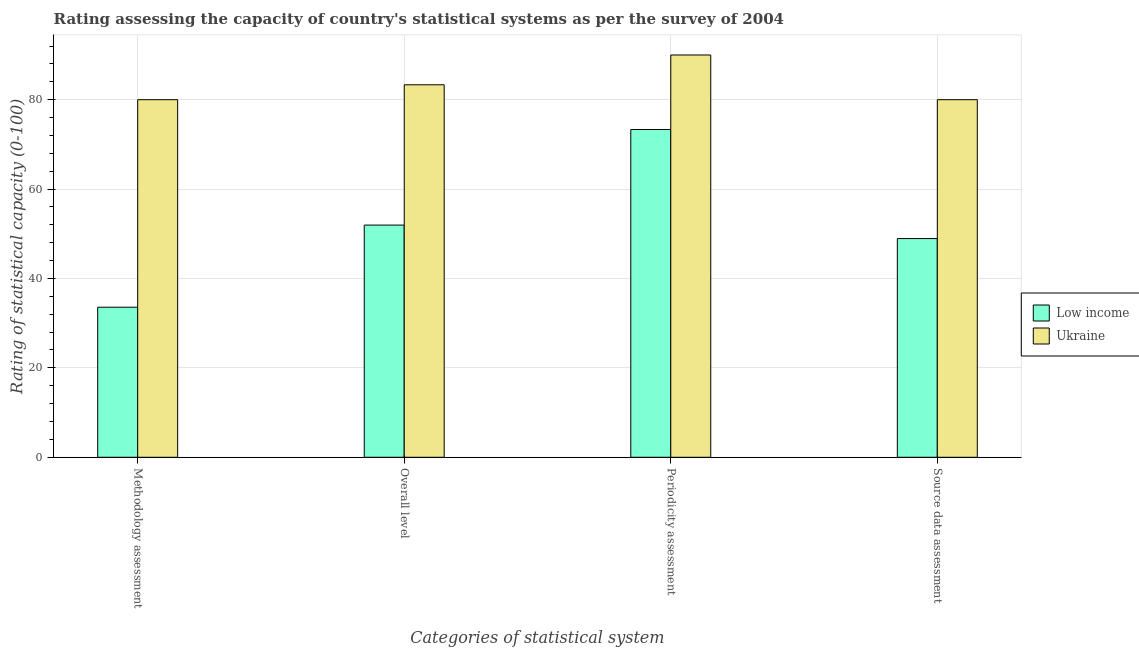How many different coloured bars are there?
Give a very brief answer. 2. What is the label of the 2nd group of bars from the left?
Your answer should be very brief. Overall level. What is the overall level rating in Low income?
Offer a very short reply. 51.94. Across all countries, what is the maximum periodicity assessment rating?
Provide a short and direct response. 90. Across all countries, what is the minimum periodicity assessment rating?
Your response must be concise. 73.33. In which country was the source data assessment rating maximum?
Offer a terse response. Ukraine. What is the total overall level rating in the graph?
Offer a terse response. 135.28. What is the difference between the overall level rating in Ukraine and that in Low income?
Make the answer very short. 31.39. What is the difference between the methodology assessment rating in Low income and the overall level rating in Ukraine?
Provide a succinct answer. -49.76. What is the average periodicity assessment rating per country?
Offer a very short reply. 81.67. What is the difference between the source data assessment rating and overall level rating in Ukraine?
Ensure brevity in your answer.  -3.33. In how many countries, is the source data assessment rating greater than 72 ?
Offer a very short reply. 1. What is the ratio of the overall level rating in Low income to that in Ukraine?
Your answer should be very brief. 0.62. Is the methodology assessment rating in Ukraine less than that in Low income?
Give a very brief answer. No. What is the difference between the highest and the second highest methodology assessment rating?
Ensure brevity in your answer.  46.43. What is the difference between the highest and the lowest overall level rating?
Provide a succinct answer. 31.39. In how many countries, is the source data assessment rating greater than the average source data assessment rating taken over all countries?
Provide a short and direct response. 1. Is the sum of the methodology assessment rating in Ukraine and Low income greater than the maximum overall level rating across all countries?
Your answer should be very brief. Yes. What does the 2nd bar from the left in Methodology assessment represents?
Ensure brevity in your answer.  Ukraine. What does the 2nd bar from the right in Overall level represents?
Your answer should be compact. Low income. How many bars are there?
Provide a succinct answer. 8. Are all the bars in the graph horizontal?
Your response must be concise. No. What is the difference between two consecutive major ticks on the Y-axis?
Keep it short and to the point. 20. Are the values on the major ticks of Y-axis written in scientific E-notation?
Your answer should be compact. No. Does the graph contain grids?
Provide a succinct answer. Yes. What is the title of the graph?
Provide a short and direct response. Rating assessing the capacity of country's statistical systems as per the survey of 2004 . What is the label or title of the X-axis?
Make the answer very short. Categories of statistical system. What is the label or title of the Y-axis?
Offer a very short reply. Rating of statistical capacity (0-100). What is the Rating of statistical capacity (0-100) in Low income in Methodology assessment?
Your response must be concise. 33.57. What is the Rating of statistical capacity (0-100) of Low income in Overall level?
Your answer should be compact. 51.94. What is the Rating of statistical capacity (0-100) of Ukraine in Overall level?
Keep it short and to the point. 83.33. What is the Rating of statistical capacity (0-100) in Low income in Periodicity assessment?
Your response must be concise. 73.33. What is the Rating of statistical capacity (0-100) of Ukraine in Periodicity assessment?
Your response must be concise. 90. What is the Rating of statistical capacity (0-100) in Low income in Source data assessment?
Give a very brief answer. 48.93. What is the Rating of statistical capacity (0-100) of Ukraine in Source data assessment?
Your answer should be very brief. 80. Across all Categories of statistical system, what is the maximum Rating of statistical capacity (0-100) of Low income?
Provide a succinct answer. 73.33. Across all Categories of statistical system, what is the maximum Rating of statistical capacity (0-100) of Ukraine?
Make the answer very short. 90. Across all Categories of statistical system, what is the minimum Rating of statistical capacity (0-100) of Low income?
Your answer should be very brief. 33.57. Across all Categories of statistical system, what is the minimum Rating of statistical capacity (0-100) of Ukraine?
Your answer should be very brief. 80. What is the total Rating of statistical capacity (0-100) in Low income in the graph?
Make the answer very short. 207.78. What is the total Rating of statistical capacity (0-100) of Ukraine in the graph?
Your response must be concise. 333.33. What is the difference between the Rating of statistical capacity (0-100) in Low income in Methodology assessment and that in Overall level?
Offer a very short reply. -18.37. What is the difference between the Rating of statistical capacity (0-100) in Ukraine in Methodology assessment and that in Overall level?
Make the answer very short. -3.33. What is the difference between the Rating of statistical capacity (0-100) in Low income in Methodology assessment and that in Periodicity assessment?
Provide a succinct answer. -39.76. What is the difference between the Rating of statistical capacity (0-100) in Low income in Methodology assessment and that in Source data assessment?
Offer a very short reply. -15.36. What is the difference between the Rating of statistical capacity (0-100) of Ukraine in Methodology assessment and that in Source data assessment?
Your response must be concise. 0. What is the difference between the Rating of statistical capacity (0-100) of Low income in Overall level and that in Periodicity assessment?
Your response must be concise. -21.39. What is the difference between the Rating of statistical capacity (0-100) of Ukraine in Overall level and that in Periodicity assessment?
Give a very brief answer. -6.67. What is the difference between the Rating of statistical capacity (0-100) in Low income in Overall level and that in Source data assessment?
Ensure brevity in your answer.  3.02. What is the difference between the Rating of statistical capacity (0-100) in Low income in Periodicity assessment and that in Source data assessment?
Your answer should be compact. 24.4. What is the difference between the Rating of statistical capacity (0-100) in Low income in Methodology assessment and the Rating of statistical capacity (0-100) in Ukraine in Overall level?
Provide a short and direct response. -49.76. What is the difference between the Rating of statistical capacity (0-100) of Low income in Methodology assessment and the Rating of statistical capacity (0-100) of Ukraine in Periodicity assessment?
Offer a very short reply. -56.43. What is the difference between the Rating of statistical capacity (0-100) in Low income in Methodology assessment and the Rating of statistical capacity (0-100) in Ukraine in Source data assessment?
Offer a very short reply. -46.43. What is the difference between the Rating of statistical capacity (0-100) of Low income in Overall level and the Rating of statistical capacity (0-100) of Ukraine in Periodicity assessment?
Your answer should be compact. -38.06. What is the difference between the Rating of statistical capacity (0-100) of Low income in Overall level and the Rating of statistical capacity (0-100) of Ukraine in Source data assessment?
Your answer should be very brief. -28.06. What is the difference between the Rating of statistical capacity (0-100) of Low income in Periodicity assessment and the Rating of statistical capacity (0-100) of Ukraine in Source data assessment?
Make the answer very short. -6.67. What is the average Rating of statistical capacity (0-100) in Low income per Categories of statistical system?
Provide a short and direct response. 51.94. What is the average Rating of statistical capacity (0-100) of Ukraine per Categories of statistical system?
Offer a very short reply. 83.33. What is the difference between the Rating of statistical capacity (0-100) of Low income and Rating of statistical capacity (0-100) of Ukraine in Methodology assessment?
Your response must be concise. -46.43. What is the difference between the Rating of statistical capacity (0-100) of Low income and Rating of statistical capacity (0-100) of Ukraine in Overall level?
Make the answer very short. -31.39. What is the difference between the Rating of statistical capacity (0-100) of Low income and Rating of statistical capacity (0-100) of Ukraine in Periodicity assessment?
Ensure brevity in your answer.  -16.67. What is the difference between the Rating of statistical capacity (0-100) in Low income and Rating of statistical capacity (0-100) in Ukraine in Source data assessment?
Keep it short and to the point. -31.07. What is the ratio of the Rating of statistical capacity (0-100) of Low income in Methodology assessment to that in Overall level?
Provide a succinct answer. 0.65. What is the ratio of the Rating of statistical capacity (0-100) in Ukraine in Methodology assessment to that in Overall level?
Give a very brief answer. 0.96. What is the ratio of the Rating of statistical capacity (0-100) in Low income in Methodology assessment to that in Periodicity assessment?
Keep it short and to the point. 0.46. What is the ratio of the Rating of statistical capacity (0-100) in Ukraine in Methodology assessment to that in Periodicity assessment?
Ensure brevity in your answer.  0.89. What is the ratio of the Rating of statistical capacity (0-100) of Low income in Methodology assessment to that in Source data assessment?
Your answer should be compact. 0.69. What is the ratio of the Rating of statistical capacity (0-100) in Low income in Overall level to that in Periodicity assessment?
Your response must be concise. 0.71. What is the ratio of the Rating of statistical capacity (0-100) in Ukraine in Overall level to that in Periodicity assessment?
Provide a short and direct response. 0.93. What is the ratio of the Rating of statistical capacity (0-100) in Low income in Overall level to that in Source data assessment?
Give a very brief answer. 1.06. What is the ratio of the Rating of statistical capacity (0-100) in Ukraine in Overall level to that in Source data assessment?
Keep it short and to the point. 1.04. What is the ratio of the Rating of statistical capacity (0-100) in Low income in Periodicity assessment to that in Source data assessment?
Give a very brief answer. 1.5. What is the difference between the highest and the second highest Rating of statistical capacity (0-100) of Low income?
Your answer should be compact. 21.39. What is the difference between the highest and the lowest Rating of statistical capacity (0-100) in Low income?
Provide a succinct answer. 39.76. What is the difference between the highest and the lowest Rating of statistical capacity (0-100) of Ukraine?
Make the answer very short. 10. 